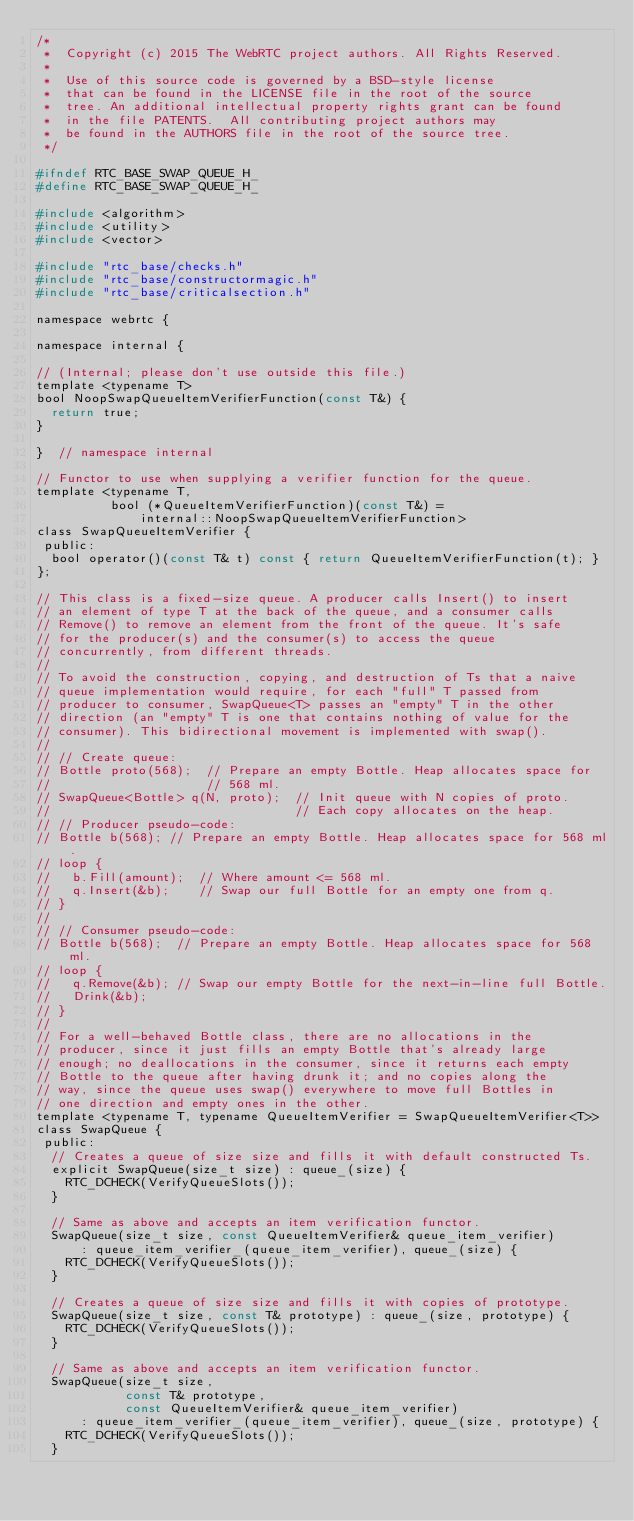Convert code to text. <code><loc_0><loc_0><loc_500><loc_500><_C_>/*
 *  Copyright (c) 2015 The WebRTC project authors. All Rights Reserved.
 *
 *  Use of this source code is governed by a BSD-style license
 *  that can be found in the LICENSE file in the root of the source
 *  tree. An additional intellectual property rights grant can be found
 *  in the file PATENTS.  All contributing project authors may
 *  be found in the AUTHORS file in the root of the source tree.
 */

#ifndef RTC_BASE_SWAP_QUEUE_H_
#define RTC_BASE_SWAP_QUEUE_H_

#include <algorithm>
#include <utility>
#include <vector>

#include "rtc_base/checks.h"
#include "rtc_base/constructormagic.h"
#include "rtc_base/criticalsection.h"

namespace webrtc {

namespace internal {

// (Internal; please don't use outside this file.)
template <typename T>
bool NoopSwapQueueItemVerifierFunction(const T&) {
  return true;
}

}  // namespace internal

// Functor to use when supplying a verifier function for the queue.
template <typename T,
          bool (*QueueItemVerifierFunction)(const T&) =
              internal::NoopSwapQueueItemVerifierFunction>
class SwapQueueItemVerifier {
 public:
  bool operator()(const T& t) const { return QueueItemVerifierFunction(t); }
};

// This class is a fixed-size queue. A producer calls Insert() to insert
// an element of type T at the back of the queue, and a consumer calls
// Remove() to remove an element from the front of the queue. It's safe
// for the producer(s) and the consumer(s) to access the queue
// concurrently, from different threads.
//
// To avoid the construction, copying, and destruction of Ts that a naive
// queue implementation would require, for each "full" T passed from
// producer to consumer, SwapQueue<T> passes an "empty" T in the other
// direction (an "empty" T is one that contains nothing of value for the
// consumer). This bidirectional movement is implemented with swap().
//
// // Create queue:
// Bottle proto(568);  // Prepare an empty Bottle. Heap allocates space for
//                     // 568 ml.
// SwapQueue<Bottle> q(N, proto);  // Init queue with N copies of proto.
//                                 // Each copy allocates on the heap.
// // Producer pseudo-code:
// Bottle b(568); // Prepare an empty Bottle. Heap allocates space for 568 ml.
// loop {
//   b.Fill(amount);  // Where amount <= 568 ml.
//   q.Insert(&b);    // Swap our full Bottle for an empty one from q.
// }
//
// // Consumer pseudo-code:
// Bottle b(568);  // Prepare an empty Bottle. Heap allocates space for 568 ml.
// loop {
//   q.Remove(&b); // Swap our empty Bottle for the next-in-line full Bottle.
//   Drink(&b);
// }
//
// For a well-behaved Bottle class, there are no allocations in the
// producer, since it just fills an empty Bottle that's already large
// enough; no deallocations in the consumer, since it returns each empty
// Bottle to the queue after having drunk it; and no copies along the
// way, since the queue uses swap() everywhere to move full Bottles in
// one direction and empty ones in the other.
template <typename T, typename QueueItemVerifier = SwapQueueItemVerifier<T>>
class SwapQueue {
 public:
  // Creates a queue of size size and fills it with default constructed Ts.
  explicit SwapQueue(size_t size) : queue_(size) {
    RTC_DCHECK(VerifyQueueSlots());
  }

  // Same as above and accepts an item verification functor.
  SwapQueue(size_t size, const QueueItemVerifier& queue_item_verifier)
      : queue_item_verifier_(queue_item_verifier), queue_(size) {
    RTC_DCHECK(VerifyQueueSlots());
  }

  // Creates a queue of size size and fills it with copies of prototype.
  SwapQueue(size_t size, const T& prototype) : queue_(size, prototype) {
    RTC_DCHECK(VerifyQueueSlots());
  }

  // Same as above and accepts an item verification functor.
  SwapQueue(size_t size,
            const T& prototype,
            const QueueItemVerifier& queue_item_verifier)
      : queue_item_verifier_(queue_item_verifier), queue_(size, prototype) {
    RTC_DCHECK(VerifyQueueSlots());
  }
</code> 